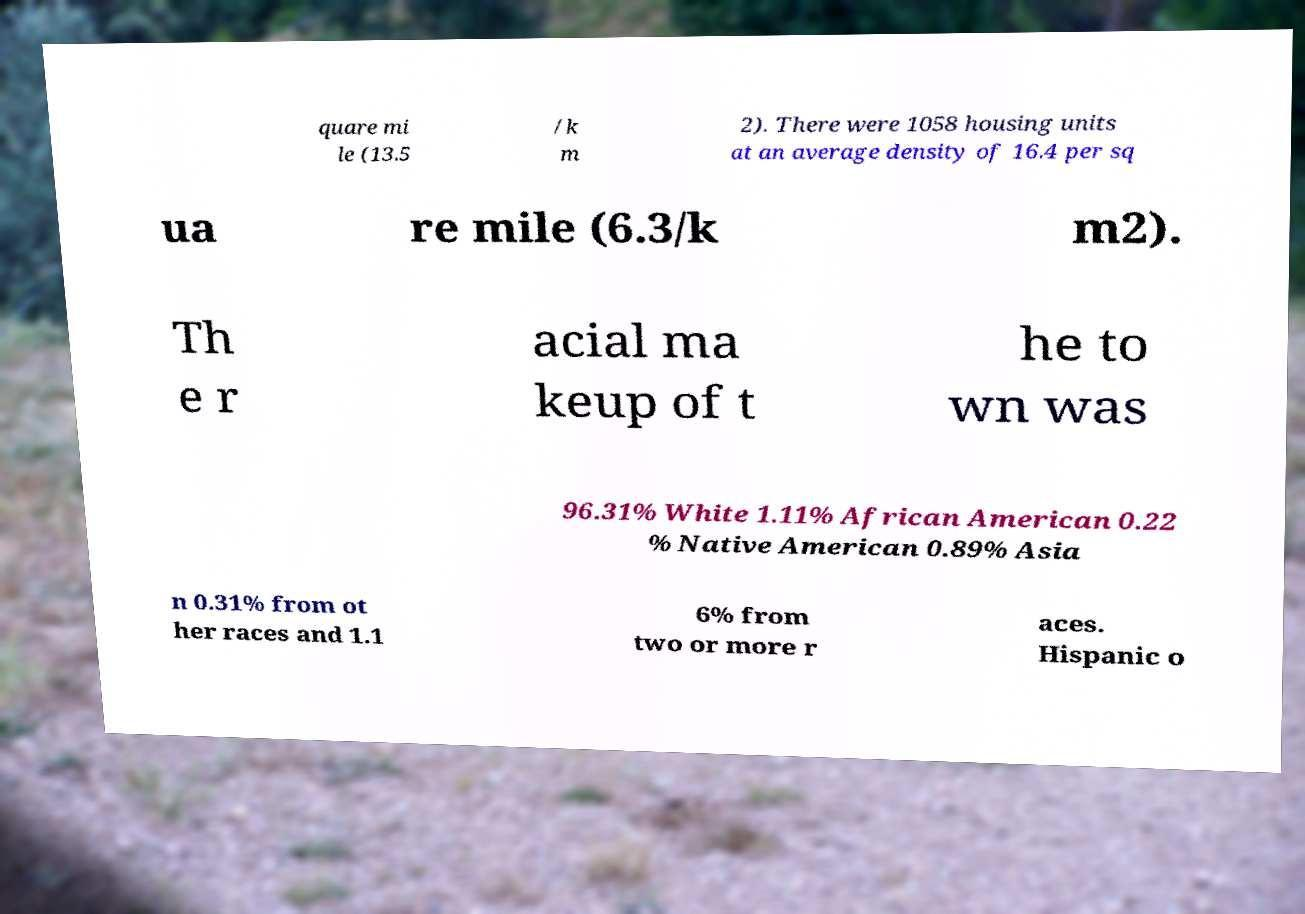There's text embedded in this image that I need extracted. Can you transcribe it verbatim? quare mi le (13.5 /k m 2). There were 1058 housing units at an average density of 16.4 per sq ua re mile (6.3/k m2). Th e r acial ma keup of t he to wn was 96.31% White 1.11% African American 0.22 % Native American 0.89% Asia n 0.31% from ot her races and 1.1 6% from two or more r aces. Hispanic o 